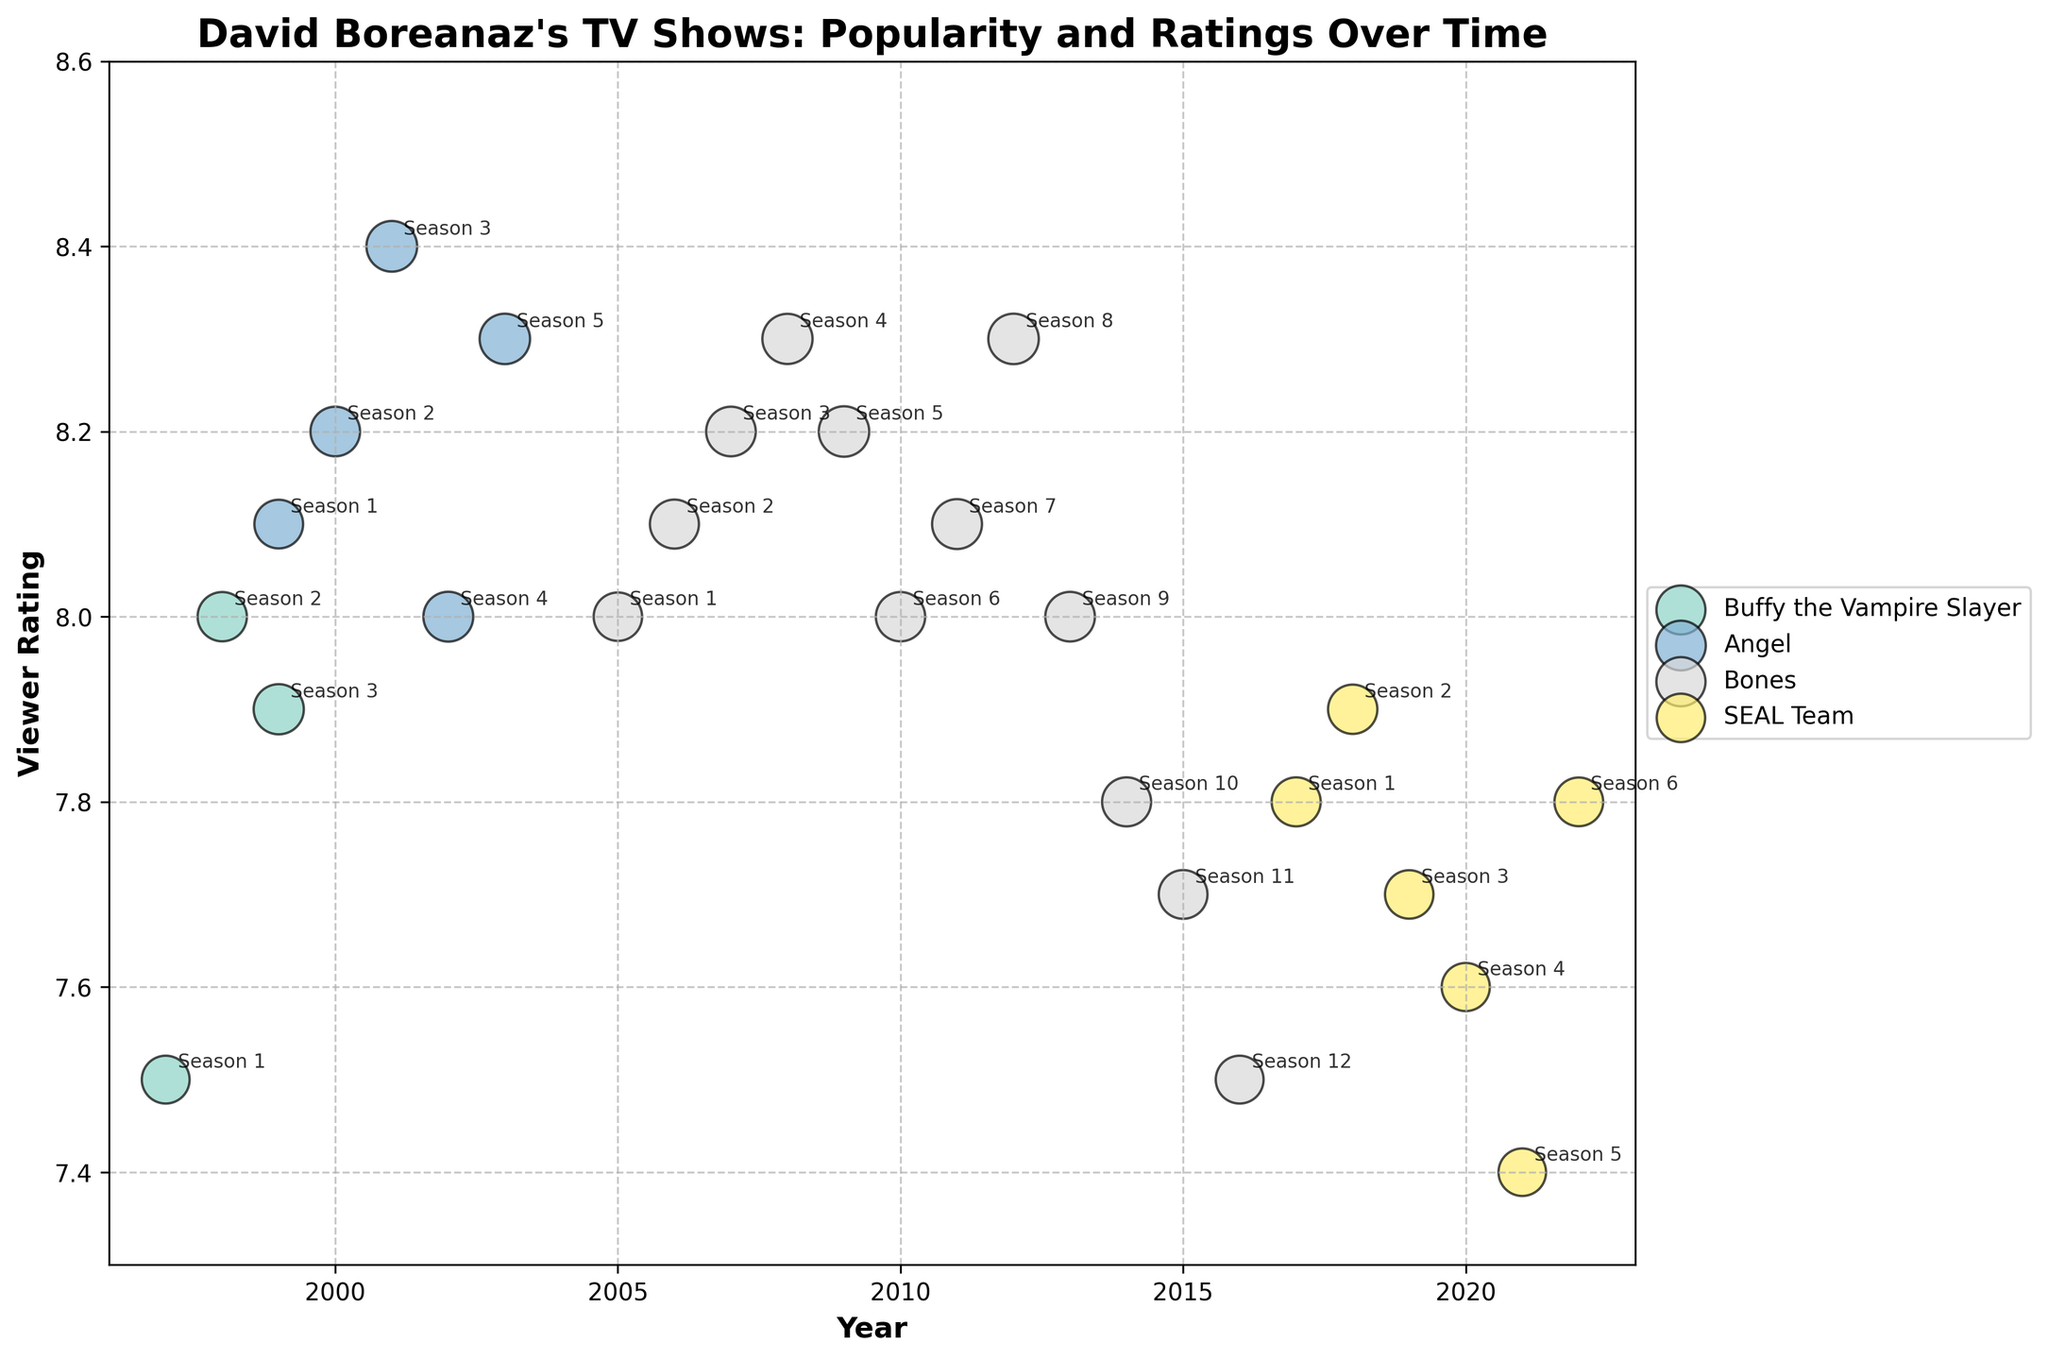What is the title of the figure? The title can be found at the top of the plot. Look for large, bold text that summarizes the content.
Answer: David Boreanaz's TV Shows: Popularity and Ratings Over Time Which TV show has the highest viewer rating? To determine this, identify the data point with the highest position on the vertical axis, which represents viewer ratings.
Answer: Angel Which TV show had the lowest viewer rating in the given period? Find the data point with the lowest position on the vertical axis, representing the lowest rating score.
Answer: SEAL Team How many TV shows are illustrated in the figure? Count the number of distinct shows represented by different colors and labeled in the legend.
Answer: 4 Which season of "Bones" had the highest popularity score? Locate the data points corresponding to "Bones" and find the one with the largest bubble, indicating the highest popularity score.
Answer: Season 8 What is the trend of viewer ratings for "Buffy the Vampire Slayer" over the years shown? Observe the progression of "Buffy the Vampire Slayer" data points along the vertical axis from the initial year to the final year.
Answer: Increasing in Season 2, then slightly decreasing in Season 3 Compare the average viewer ratings of "Angel" and "Bones". Which one is higher? Calculate the average viewer rating for each show by summing the ratings and dividing by the number of seasons. Compare the two averages.
Answer: Angel Across all TV shows, which year had the highest combined viewer rating score? Sum the viewer ratings for each year across all shows and find the year with the highest total.
Answer: 2001 Did "SEAL Team" have an increasing or decreasing trend in popularity scores over the years? Look at the size of the bubbles representing "SEAL Team" over the years 2017 to 2022. Determine if the bubble sizes are generally increasing or decreasing.
Answer: Decreasing Which period for "Bones" has the lowest viewer rating? Identify the data point for "Bones" with the lowest position on the vertical axis. Check its corresponding period.
Answer: Season 12 